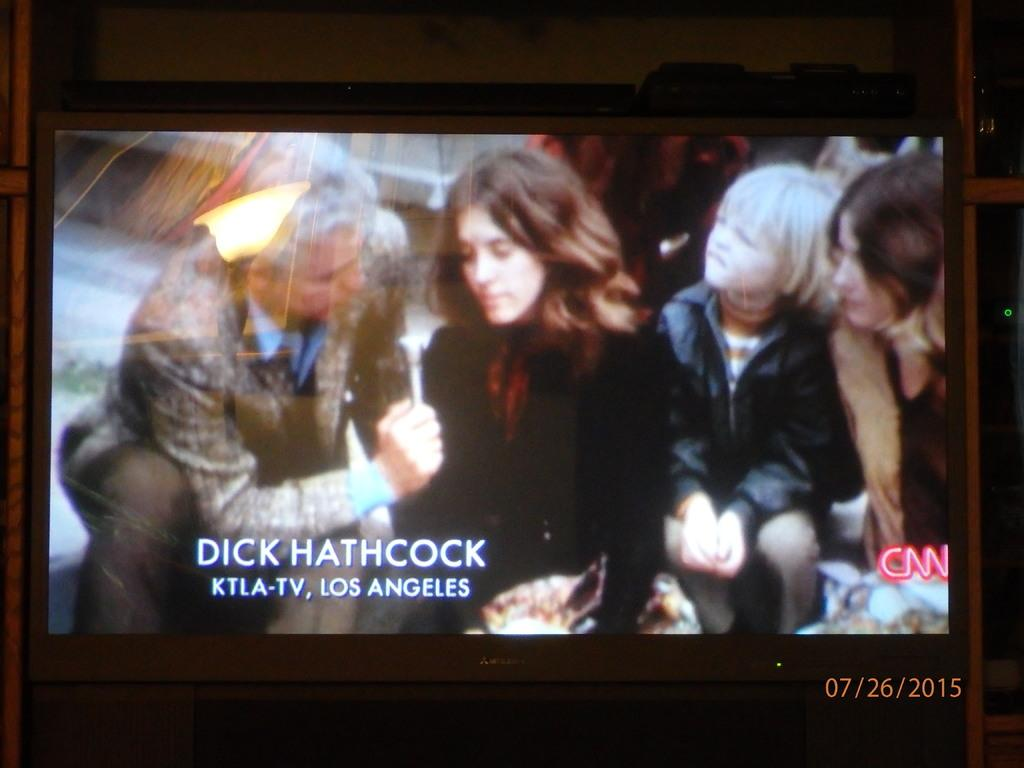<image>
Relay a brief, clear account of the picture shown. Dick Hathcock from KTLA-TV interviews someone for CNN. 